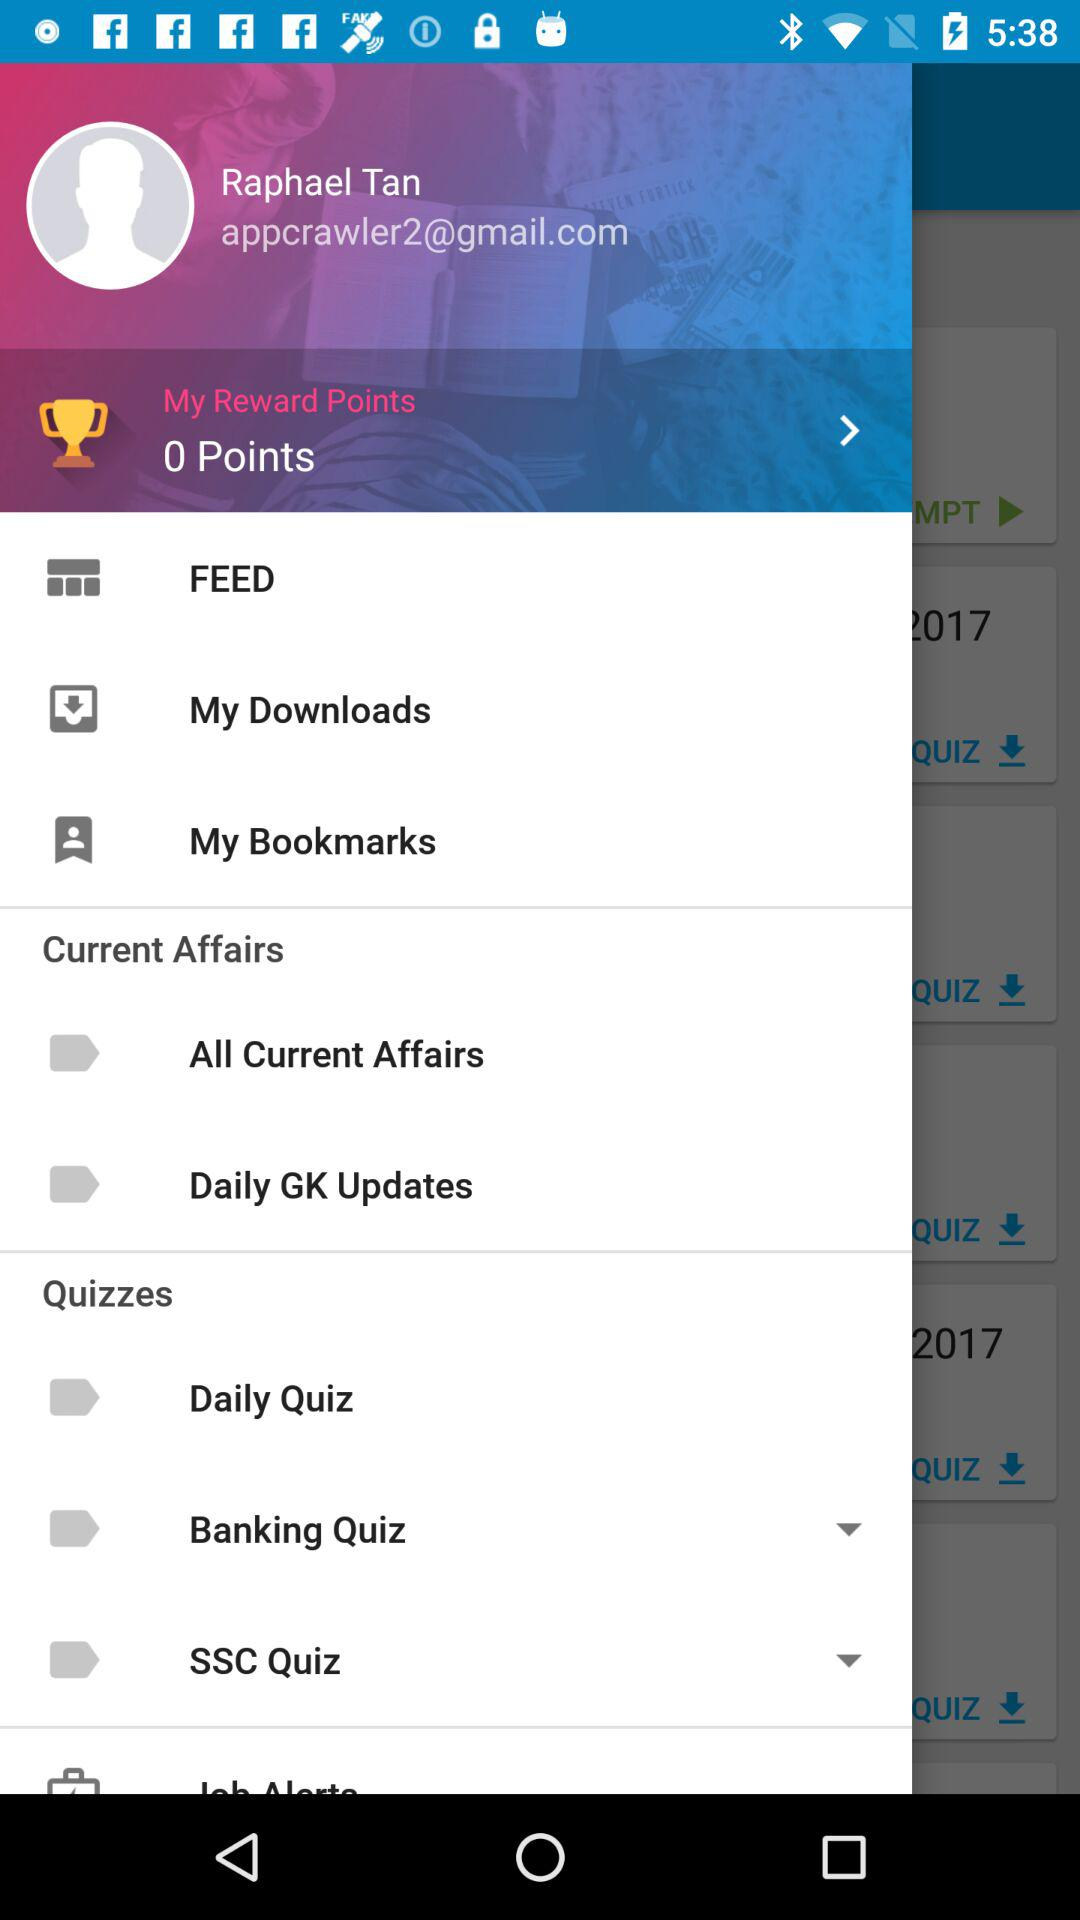What is the given "Gmail" address? The given "Gmail" address is appcrawler2@gmail.com. 